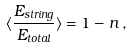Convert formula to latex. <formula><loc_0><loc_0><loc_500><loc_500>\langle \frac { E _ { s t r i n g } } { E _ { t o t a l } } \rangle = 1 - n \, ,</formula> 